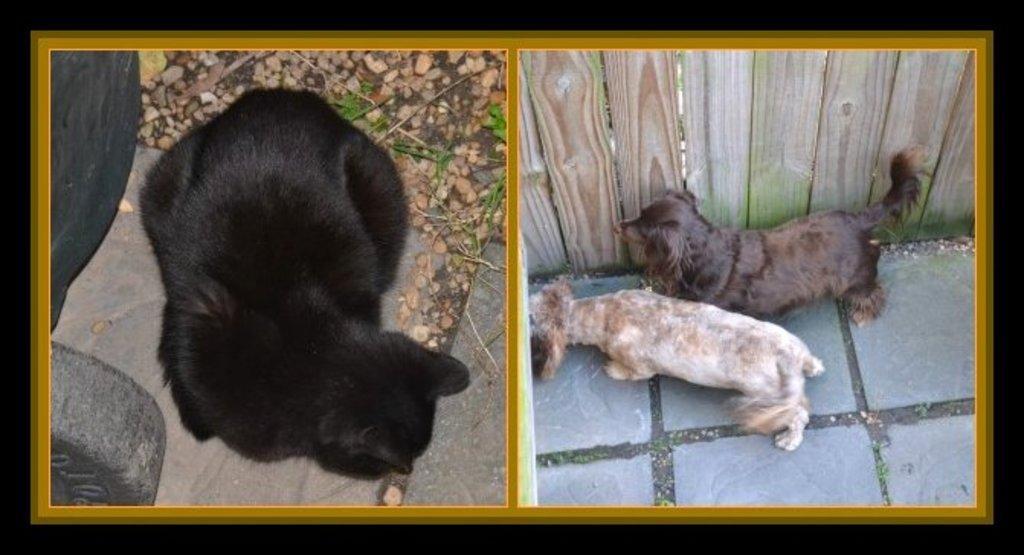Could you give a brief overview of what you see in this image? In this picture we can see a frame on the black surface and in this frame we can see animals, stones, wall and some objects. 